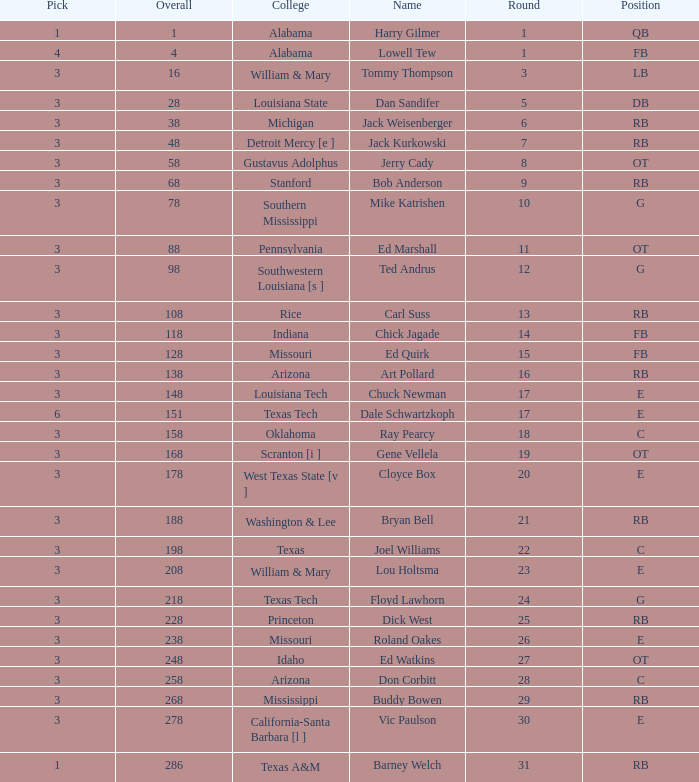Which Overall has a Name of bob anderson, and a Round smaller than 9? None. 